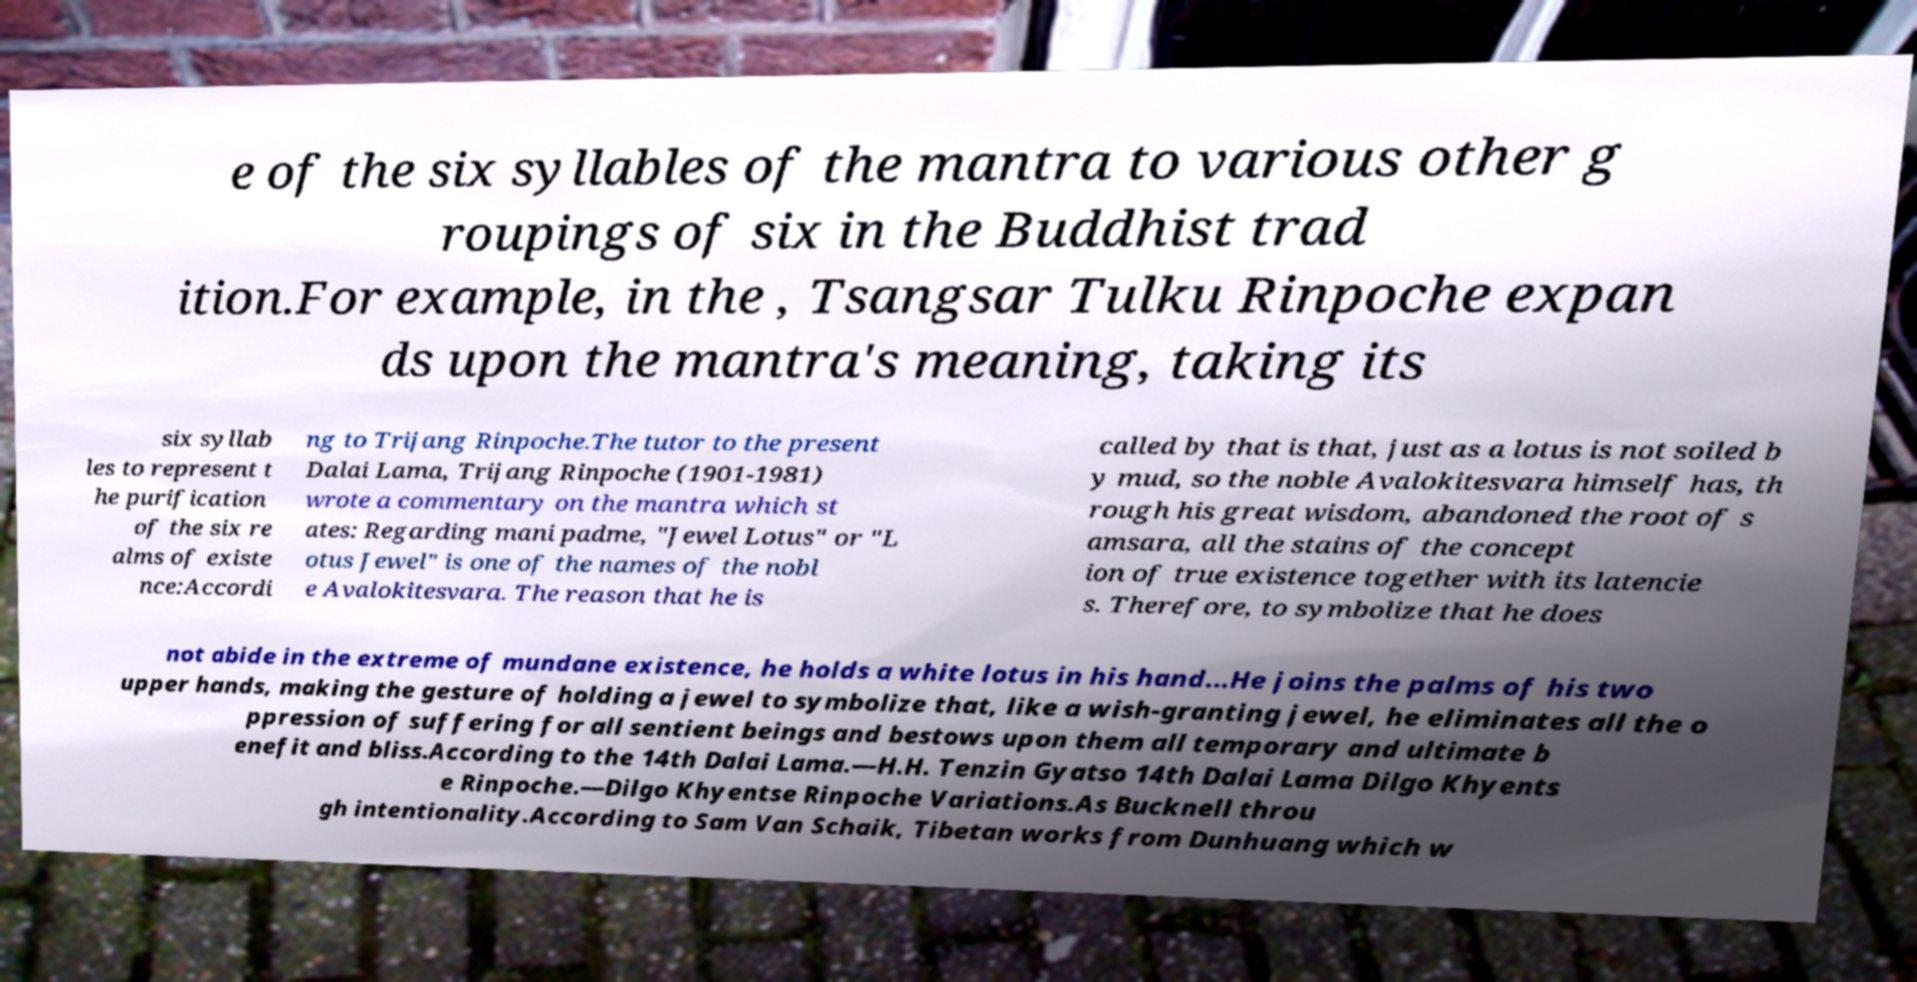Please read and relay the text visible in this image. What does it say? e of the six syllables of the mantra to various other g roupings of six in the Buddhist trad ition.For example, in the , Tsangsar Tulku Rinpoche expan ds upon the mantra's meaning, taking its six syllab les to represent t he purification of the six re alms of existe nce:Accordi ng to Trijang Rinpoche.The tutor to the present Dalai Lama, Trijang Rinpoche (1901-1981) wrote a commentary on the mantra which st ates: Regarding mani padme, "Jewel Lotus" or "L otus Jewel" is one of the names of the nobl e Avalokitesvara. The reason that he is called by that is that, just as a lotus is not soiled b y mud, so the noble Avalokitesvara himself has, th rough his great wisdom, abandoned the root of s amsara, all the stains of the concept ion of true existence together with its latencie s. Therefore, to symbolize that he does not abide in the extreme of mundane existence, he holds a white lotus in his hand...He joins the palms of his two upper hands, making the gesture of holding a jewel to symbolize that, like a wish-granting jewel, he eliminates all the o ppression of suffering for all sentient beings and bestows upon them all temporary and ultimate b enefit and bliss.According to the 14th Dalai Lama.—H.H. Tenzin Gyatso 14th Dalai Lama Dilgo Khyents e Rinpoche.—Dilgo Khyentse Rinpoche Variations.As Bucknell throu gh intentionality.According to Sam Van Schaik, Tibetan works from Dunhuang which w 